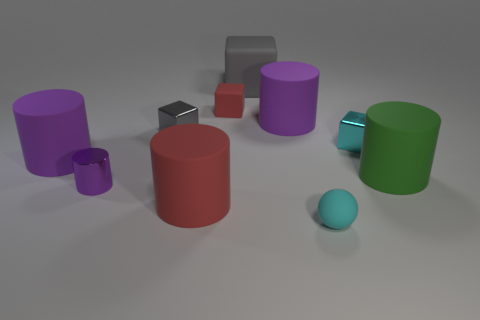Are there any other things that are the same shape as the small cyan rubber object?
Keep it short and to the point. No. How many red rubber cylinders are right of the cyan sphere?
Ensure brevity in your answer.  0. Are there any balls made of the same material as the big red cylinder?
Offer a terse response. Yes. Are there more tiny cyan things in front of the tiny purple object than cyan blocks that are in front of the large green cylinder?
Keep it short and to the point. Yes. What is the size of the red cube?
Your answer should be very brief. Small. There is a big green object that is in front of the tiny gray block; what is its shape?
Provide a short and direct response. Cylinder. Is the tiny gray shiny thing the same shape as the cyan metallic object?
Offer a very short reply. Yes. Is the number of purple rubber cylinders behind the red cube the same as the number of small rubber cubes?
Keep it short and to the point. No. The cyan shiny thing has what shape?
Provide a succinct answer. Cube. There is a purple matte cylinder on the left side of the large red matte cylinder; is its size the same as the shiny cube on the left side of the small cyan cube?
Your answer should be very brief. No. 